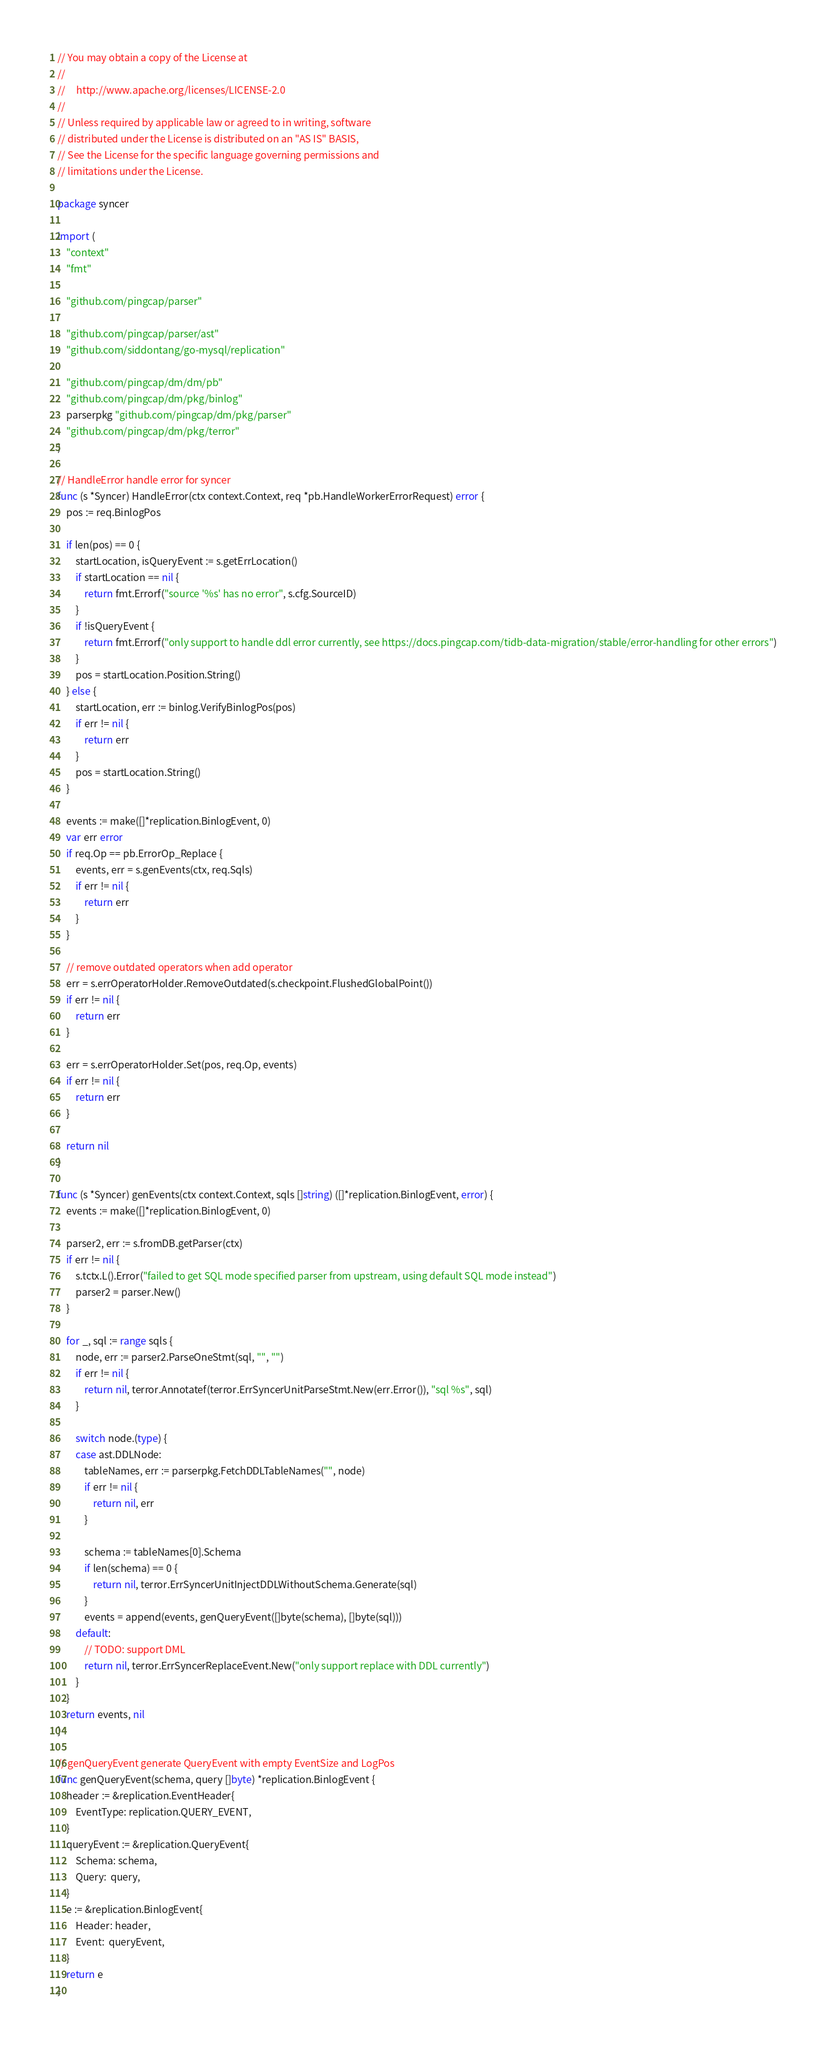Convert code to text. <code><loc_0><loc_0><loc_500><loc_500><_Go_>// You may obtain a copy of the License at
//
//     http://www.apache.org/licenses/LICENSE-2.0
//
// Unless required by applicable law or agreed to in writing, software
// distributed under the License is distributed on an "AS IS" BASIS,
// See the License for the specific language governing permissions and
// limitations under the License.

package syncer

import (
	"context"
	"fmt"

	"github.com/pingcap/parser"

	"github.com/pingcap/parser/ast"
	"github.com/siddontang/go-mysql/replication"

	"github.com/pingcap/dm/dm/pb"
	"github.com/pingcap/dm/pkg/binlog"
	parserpkg "github.com/pingcap/dm/pkg/parser"
	"github.com/pingcap/dm/pkg/terror"
)

// HandleError handle error for syncer
func (s *Syncer) HandleError(ctx context.Context, req *pb.HandleWorkerErrorRequest) error {
	pos := req.BinlogPos

	if len(pos) == 0 {
		startLocation, isQueryEvent := s.getErrLocation()
		if startLocation == nil {
			return fmt.Errorf("source '%s' has no error", s.cfg.SourceID)
		}
		if !isQueryEvent {
			return fmt.Errorf("only support to handle ddl error currently, see https://docs.pingcap.com/tidb-data-migration/stable/error-handling for other errors")
		}
		pos = startLocation.Position.String()
	} else {
		startLocation, err := binlog.VerifyBinlogPos(pos)
		if err != nil {
			return err
		}
		pos = startLocation.String()
	}

	events := make([]*replication.BinlogEvent, 0)
	var err error
	if req.Op == pb.ErrorOp_Replace {
		events, err = s.genEvents(ctx, req.Sqls)
		if err != nil {
			return err
		}
	}

	// remove outdated operators when add operator
	err = s.errOperatorHolder.RemoveOutdated(s.checkpoint.FlushedGlobalPoint())
	if err != nil {
		return err
	}

	err = s.errOperatorHolder.Set(pos, req.Op, events)
	if err != nil {
		return err
	}

	return nil
}

func (s *Syncer) genEvents(ctx context.Context, sqls []string) ([]*replication.BinlogEvent, error) {
	events := make([]*replication.BinlogEvent, 0)

	parser2, err := s.fromDB.getParser(ctx)
	if err != nil {
		s.tctx.L().Error("failed to get SQL mode specified parser from upstream, using default SQL mode instead")
		parser2 = parser.New()
	}

	for _, sql := range sqls {
		node, err := parser2.ParseOneStmt(sql, "", "")
		if err != nil {
			return nil, terror.Annotatef(terror.ErrSyncerUnitParseStmt.New(err.Error()), "sql %s", sql)
		}

		switch node.(type) {
		case ast.DDLNode:
			tableNames, err := parserpkg.FetchDDLTableNames("", node)
			if err != nil {
				return nil, err
			}

			schema := tableNames[0].Schema
			if len(schema) == 0 {
				return nil, terror.ErrSyncerUnitInjectDDLWithoutSchema.Generate(sql)
			}
			events = append(events, genQueryEvent([]byte(schema), []byte(sql)))
		default:
			// TODO: support DML
			return nil, terror.ErrSyncerReplaceEvent.New("only support replace with DDL currently")
		}
	}
	return events, nil
}

// genQueryEvent generate QueryEvent with empty EventSize and LogPos
func genQueryEvent(schema, query []byte) *replication.BinlogEvent {
	header := &replication.EventHeader{
		EventType: replication.QUERY_EVENT,
	}
	queryEvent := &replication.QueryEvent{
		Schema: schema,
		Query:  query,
	}
	e := &replication.BinlogEvent{
		Header: header,
		Event:  queryEvent,
	}
	return e
}
</code> 